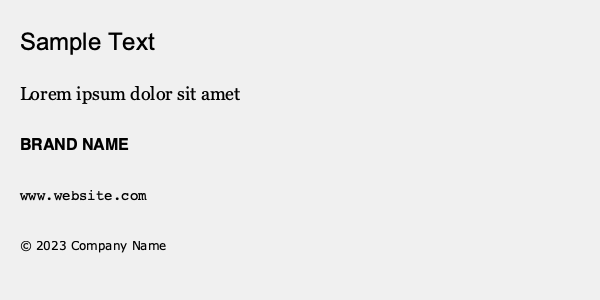As a branding expert, which font pairing principle is best exemplified in the sample text above, and how does it contribute to effective visual hierarchy? To answer this question, let's analyze the font pairings and visual hierarchy in the sample text:

1. The title "Sample Text" uses a bold, sans-serif font (Arial), which stands out due to its large size and weight.

2. The body text "Lorem ipsum dolor sit amet" uses a serif font (Georgia), creating a contrast with the title.

3. The brand name uses a bold, sans-serif font (Helvetica), similar to the title but in a smaller size.

4. The website URL uses a monospace font (Courier), differentiating it from other text elements.

5. The copyright information uses a small, sans-serif font (Verdana), clearly separating it from the main content.

The principle best exemplified here is contrast in font styles and sizes. This creates a clear visual hierarchy:

a) The title is most prominent, grabbing attention first.
b) The body text is easily readable and distinct from the title.
c) The brand name stands out but doesn't overpower the title.
d) The website and copyright information are visually separate and less prominent.

This pairing principle contributes to effective visual hierarchy by:
1. Guiding the reader's eye through the content in order of importance.
2. Creating distinct roles for each text element.
3. Enhancing readability and overall visual appeal.
4. Maintaining brand consistency while differentiating various types of information.
Answer: Contrast in font styles and sizes, creating clear visual hierarchy 